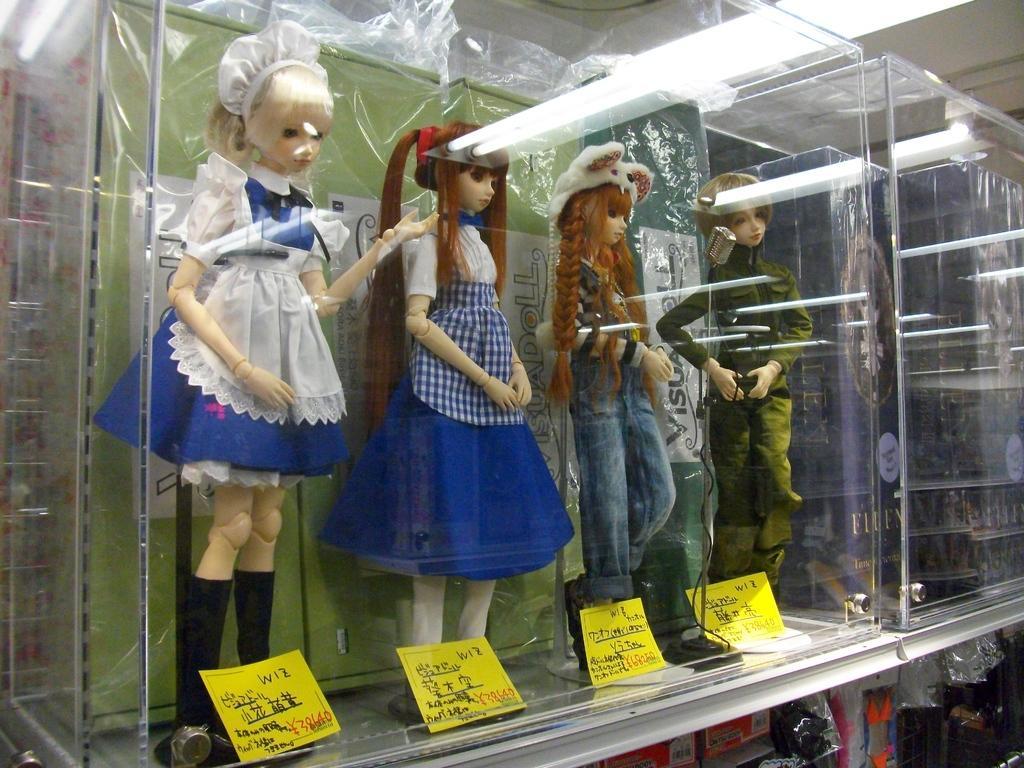Please provide a concise description of this image. In the picture we can see a glass box in it, we can see four girl doll which are in standing position and under the foot of the dolls we can see yellow color slips with some information in it and beside the glass box we can see another glass box on the desk and to the ceiling we can see the light. 